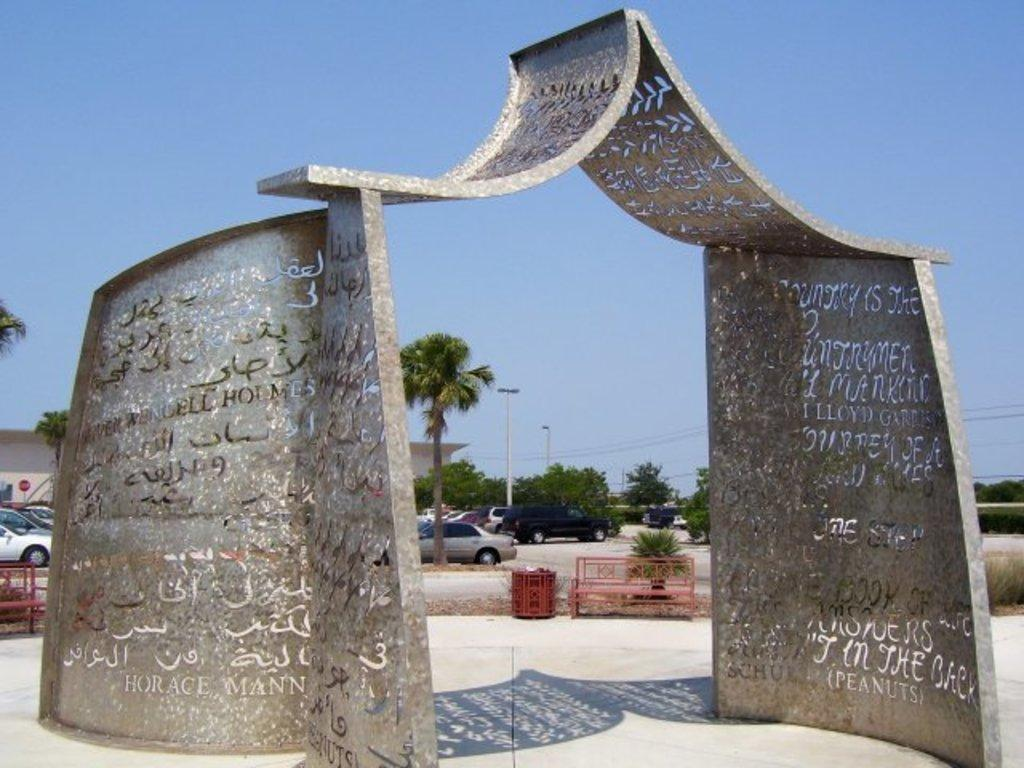What is the main subject in the center of the image? There is a sculpture in the center of the image. What can be seen in the background of the image? In the background of the image, there are cars, at least one building, trees, poles, and the sky. How many elements can be identified in the background of the image? There are five elements in the background of the image: cars, a building, trees, poles, and the sky. What type of committee is meeting in the image? There is no committee meeting in the image; it features a sculpture and various elements in the background. Can you see any smoke coming from the sculpture in the image? There is no smoke visible in the image; it only features a sculpture and elements in the background. 